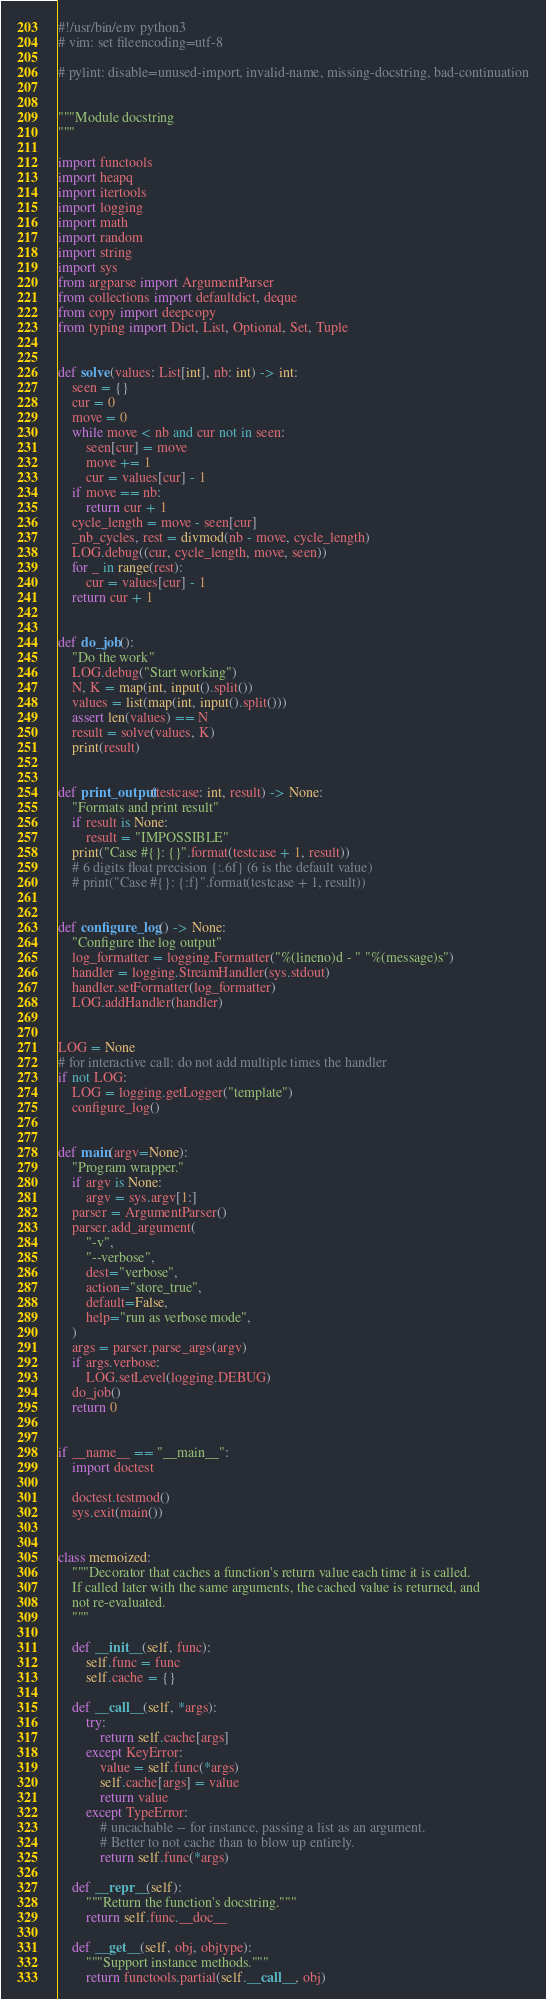Convert code to text. <code><loc_0><loc_0><loc_500><loc_500><_Python_>#!/usr/bin/env python3
# vim: set fileencoding=utf-8

# pylint: disable=unused-import, invalid-name, missing-docstring, bad-continuation


"""Module docstring
"""

import functools
import heapq
import itertools
import logging
import math
import random
import string
import sys
from argparse import ArgumentParser
from collections import defaultdict, deque
from copy import deepcopy
from typing import Dict, List, Optional, Set, Tuple


def solve(values: List[int], nb: int) -> int:
    seen = {}
    cur = 0
    move = 0
    while move < nb and cur not in seen:
        seen[cur] = move
        move += 1
        cur = values[cur] - 1
    if move == nb:
        return cur + 1
    cycle_length = move - seen[cur]
    _nb_cycles, rest = divmod(nb - move, cycle_length)
    LOG.debug((cur, cycle_length, move, seen))
    for _ in range(rest):
        cur = values[cur] - 1
    return cur + 1


def do_job():
    "Do the work"
    LOG.debug("Start working")
    N, K = map(int, input().split())
    values = list(map(int, input().split()))
    assert len(values) == N
    result = solve(values, K)
    print(result)


def print_output(testcase: int, result) -> None:
    "Formats and print result"
    if result is None:
        result = "IMPOSSIBLE"
    print("Case #{}: {}".format(testcase + 1, result))
    # 6 digits float precision {:.6f} (6 is the default value)
    # print("Case #{}: {:f}".format(testcase + 1, result))


def configure_log() -> None:
    "Configure the log output"
    log_formatter = logging.Formatter("%(lineno)d - " "%(message)s")
    handler = logging.StreamHandler(sys.stdout)
    handler.setFormatter(log_formatter)
    LOG.addHandler(handler)


LOG = None
# for interactive call: do not add multiple times the handler
if not LOG:
    LOG = logging.getLogger("template")
    configure_log()


def main(argv=None):
    "Program wrapper."
    if argv is None:
        argv = sys.argv[1:]
    parser = ArgumentParser()
    parser.add_argument(
        "-v",
        "--verbose",
        dest="verbose",
        action="store_true",
        default=False,
        help="run as verbose mode",
    )
    args = parser.parse_args(argv)
    if args.verbose:
        LOG.setLevel(logging.DEBUG)
    do_job()
    return 0


if __name__ == "__main__":
    import doctest

    doctest.testmod()
    sys.exit(main())


class memoized:
    """Decorator that caches a function's return value each time it is called.
    If called later with the same arguments, the cached value is returned, and
    not re-evaluated.
    """

    def __init__(self, func):
        self.func = func
        self.cache = {}

    def __call__(self, *args):
        try:
            return self.cache[args]
        except KeyError:
            value = self.func(*args)
            self.cache[args] = value
            return value
        except TypeError:
            # uncachable -- for instance, passing a list as an argument.
            # Better to not cache than to blow up entirely.
            return self.func(*args)

    def __repr__(self):
        """Return the function's docstring."""
        return self.func.__doc__

    def __get__(self, obj, objtype):
        """Support instance methods."""
        return functools.partial(self.__call__, obj)
</code> 